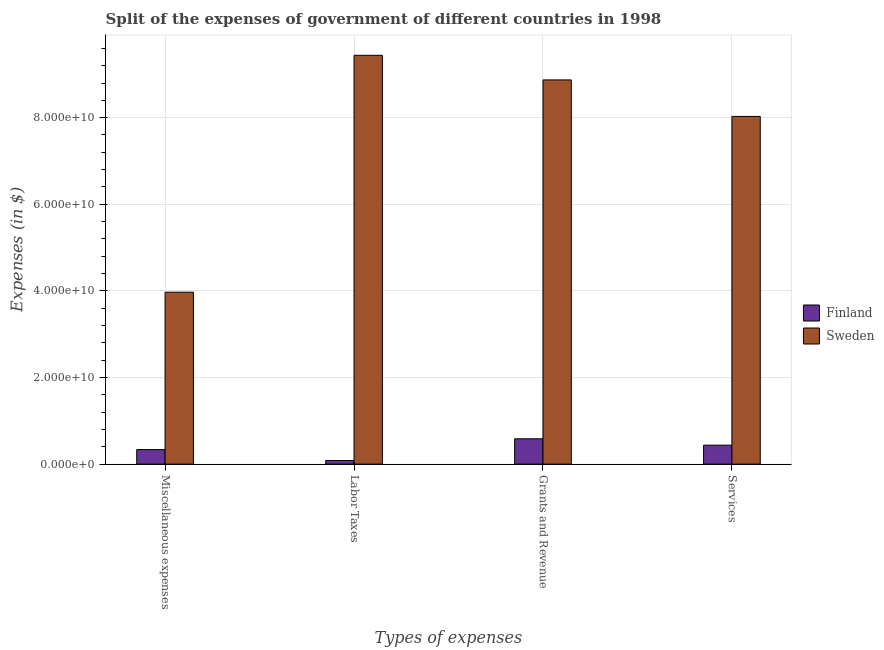Are the number of bars per tick equal to the number of legend labels?
Your answer should be compact. Yes. How many bars are there on the 4th tick from the left?
Give a very brief answer. 2. How many bars are there on the 1st tick from the right?
Provide a short and direct response. 2. What is the label of the 2nd group of bars from the left?
Offer a very short reply. Labor Taxes. What is the amount spent on grants and revenue in Finland?
Keep it short and to the point. 5.85e+09. Across all countries, what is the maximum amount spent on miscellaneous expenses?
Offer a terse response. 3.97e+1. Across all countries, what is the minimum amount spent on services?
Offer a terse response. 4.38e+09. What is the total amount spent on labor taxes in the graph?
Offer a very short reply. 9.52e+1. What is the difference between the amount spent on services in Sweden and that in Finland?
Your answer should be compact. 7.59e+1. What is the difference between the amount spent on labor taxes in Sweden and the amount spent on services in Finland?
Your answer should be very brief. 9.00e+1. What is the average amount spent on grants and revenue per country?
Offer a terse response. 4.73e+1. What is the difference between the amount spent on services and amount spent on labor taxes in Sweden?
Your answer should be compact. -1.41e+1. In how many countries, is the amount spent on labor taxes greater than 36000000000 $?
Offer a terse response. 1. What is the ratio of the amount spent on grants and revenue in Sweden to that in Finland?
Provide a short and direct response. 15.17. Is the amount spent on services in Sweden less than that in Finland?
Provide a succinct answer. No. Is the difference between the amount spent on labor taxes in Sweden and Finland greater than the difference between the amount spent on grants and revenue in Sweden and Finland?
Your answer should be very brief. Yes. What is the difference between the highest and the second highest amount spent on grants and revenue?
Make the answer very short. 8.29e+1. What is the difference between the highest and the lowest amount spent on services?
Keep it short and to the point. 7.59e+1. Is the sum of the amount spent on miscellaneous expenses in Finland and Sweden greater than the maximum amount spent on grants and revenue across all countries?
Offer a very short reply. No. How many countries are there in the graph?
Offer a very short reply. 2. Are the values on the major ticks of Y-axis written in scientific E-notation?
Give a very brief answer. Yes. Does the graph contain any zero values?
Provide a short and direct response. No. Does the graph contain grids?
Keep it short and to the point. Yes. Where does the legend appear in the graph?
Your response must be concise. Center right. What is the title of the graph?
Give a very brief answer. Split of the expenses of government of different countries in 1998. What is the label or title of the X-axis?
Offer a terse response. Types of expenses. What is the label or title of the Y-axis?
Keep it short and to the point. Expenses (in $). What is the Expenses (in $) of Finland in Miscellaneous expenses?
Provide a short and direct response. 3.36e+09. What is the Expenses (in $) of Sweden in Miscellaneous expenses?
Your answer should be compact. 3.97e+1. What is the Expenses (in $) of Finland in Labor Taxes?
Your response must be concise. 8.31e+08. What is the Expenses (in $) in Sweden in Labor Taxes?
Ensure brevity in your answer.  9.44e+1. What is the Expenses (in $) in Finland in Grants and Revenue?
Your response must be concise. 5.85e+09. What is the Expenses (in $) of Sweden in Grants and Revenue?
Offer a terse response. 8.87e+1. What is the Expenses (in $) in Finland in Services?
Provide a short and direct response. 4.38e+09. What is the Expenses (in $) in Sweden in Services?
Offer a terse response. 8.03e+1. Across all Types of expenses, what is the maximum Expenses (in $) in Finland?
Make the answer very short. 5.85e+09. Across all Types of expenses, what is the maximum Expenses (in $) in Sweden?
Your response must be concise. 9.44e+1. Across all Types of expenses, what is the minimum Expenses (in $) of Finland?
Give a very brief answer. 8.31e+08. Across all Types of expenses, what is the minimum Expenses (in $) of Sweden?
Give a very brief answer. 3.97e+1. What is the total Expenses (in $) of Finland in the graph?
Offer a very short reply. 1.44e+1. What is the total Expenses (in $) of Sweden in the graph?
Make the answer very short. 3.03e+11. What is the difference between the Expenses (in $) in Finland in Miscellaneous expenses and that in Labor Taxes?
Your answer should be compact. 2.52e+09. What is the difference between the Expenses (in $) in Sweden in Miscellaneous expenses and that in Labor Taxes?
Your response must be concise. -5.47e+1. What is the difference between the Expenses (in $) of Finland in Miscellaneous expenses and that in Grants and Revenue?
Keep it short and to the point. -2.49e+09. What is the difference between the Expenses (in $) of Sweden in Miscellaneous expenses and that in Grants and Revenue?
Your answer should be very brief. -4.90e+1. What is the difference between the Expenses (in $) of Finland in Miscellaneous expenses and that in Services?
Your response must be concise. -1.02e+09. What is the difference between the Expenses (in $) of Sweden in Miscellaneous expenses and that in Services?
Your answer should be compact. -4.06e+1. What is the difference between the Expenses (in $) of Finland in Labor Taxes and that in Grants and Revenue?
Give a very brief answer. -5.02e+09. What is the difference between the Expenses (in $) of Sweden in Labor Taxes and that in Grants and Revenue?
Provide a short and direct response. 5.68e+09. What is the difference between the Expenses (in $) in Finland in Labor Taxes and that in Services?
Your response must be concise. -3.55e+09. What is the difference between the Expenses (in $) of Sweden in Labor Taxes and that in Services?
Provide a short and direct response. 1.41e+1. What is the difference between the Expenses (in $) of Finland in Grants and Revenue and that in Services?
Your response must be concise. 1.47e+09. What is the difference between the Expenses (in $) in Sweden in Grants and Revenue and that in Services?
Give a very brief answer. 8.43e+09. What is the difference between the Expenses (in $) in Finland in Miscellaneous expenses and the Expenses (in $) in Sweden in Labor Taxes?
Offer a terse response. -9.10e+1. What is the difference between the Expenses (in $) in Finland in Miscellaneous expenses and the Expenses (in $) in Sweden in Grants and Revenue?
Your answer should be compact. -8.54e+1. What is the difference between the Expenses (in $) of Finland in Miscellaneous expenses and the Expenses (in $) of Sweden in Services?
Provide a short and direct response. -7.69e+1. What is the difference between the Expenses (in $) in Finland in Labor Taxes and the Expenses (in $) in Sweden in Grants and Revenue?
Make the answer very short. -8.79e+1. What is the difference between the Expenses (in $) of Finland in Labor Taxes and the Expenses (in $) of Sweden in Services?
Give a very brief answer. -7.95e+1. What is the difference between the Expenses (in $) in Finland in Grants and Revenue and the Expenses (in $) in Sweden in Services?
Provide a short and direct response. -7.44e+1. What is the average Expenses (in $) of Finland per Types of expenses?
Provide a short and direct response. 3.60e+09. What is the average Expenses (in $) in Sweden per Types of expenses?
Your answer should be compact. 7.58e+1. What is the difference between the Expenses (in $) of Finland and Expenses (in $) of Sweden in Miscellaneous expenses?
Give a very brief answer. -3.63e+1. What is the difference between the Expenses (in $) of Finland and Expenses (in $) of Sweden in Labor Taxes?
Keep it short and to the point. -9.36e+1. What is the difference between the Expenses (in $) in Finland and Expenses (in $) in Sweden in Grants and Revenue?
Your response must be concise. -8.29e+1. What is the difference between the Expenses (in $) of Finland and Expenses (in $) of Sweden in Services?
Your answer should be very brief. -7.59e+1. What is the ratio of the Expenses (in $) of Finland in Miscellaneous expenses to that in Labor Taxes?
Give a very brief answer. 4.04. What is the ratio of the Expenses (in $) in Sweden in Miscellaneous expenses to that in Labor Taxes?
Provide a succinct answer. 0.42. What is the ratio of the Expenses (in $) in Finland in Miscellaneous expenses to that in Grants and Revenue?
Keep it short and to the point. 0.57. What is the ratio of the Expenses (in $) of Sweden in Miscellaneous expenses to that in Grants and Revenue?
Your answer should be compact. 0.45. What is the ratio of the Expenses (in $) of Finland in Miscellaneous expenses to that in Services?
Provide a succinct answer. 0.77. What is the ratio of the Expenses (in $) of Sweden in Miscellaneous expenses to that in Services?
Make the answer very short. 0.49. What is the ratio of the Expenses (in $) of Finland in Labor Taxes to that in Grants and Revenue?
Provide a short and direct response. 0.14. What is the ratio of the Expenses (in $) of Sweden in Labor Taxes to that in Grants and Revenue?
Give a very brief answer. 1.06. What is the ratio of the Expenses (in $) in Finland in Labor Taxes to that in Services?
Make the answer very short. 0.19. What is the ratio of the Expenses (in $) in Sweden in Labor Taxes to that in Services?
Offer a very short reply. 1.18. What is the ratio of the Expenses (in $) in Finland in Grants and Revenue to that in Services?
Your answer should be very brief. 1.34. What is the ratio of the Expenses (in $) of Sweden in Grants and Revenue to that in Services?
Provide a succinct answer. 1.1. What is the difference between the highest and the second highest Expenses (in $) of Finland?
Give a very brief answer. 1.47e+09. What is the difference between the highest and the second highest Expenses (in $) in Sweden?
Provide a succinct answer. 5.68e+09. What is the difference between the highest and the lowest Expenses (in $) of Finland?
Provide a short and direct response. 5.02e+09. What is the difference between the highest and the lowest Expenses (in $) in Sweden?
Provide a succinct answer. 5.47e+1. 